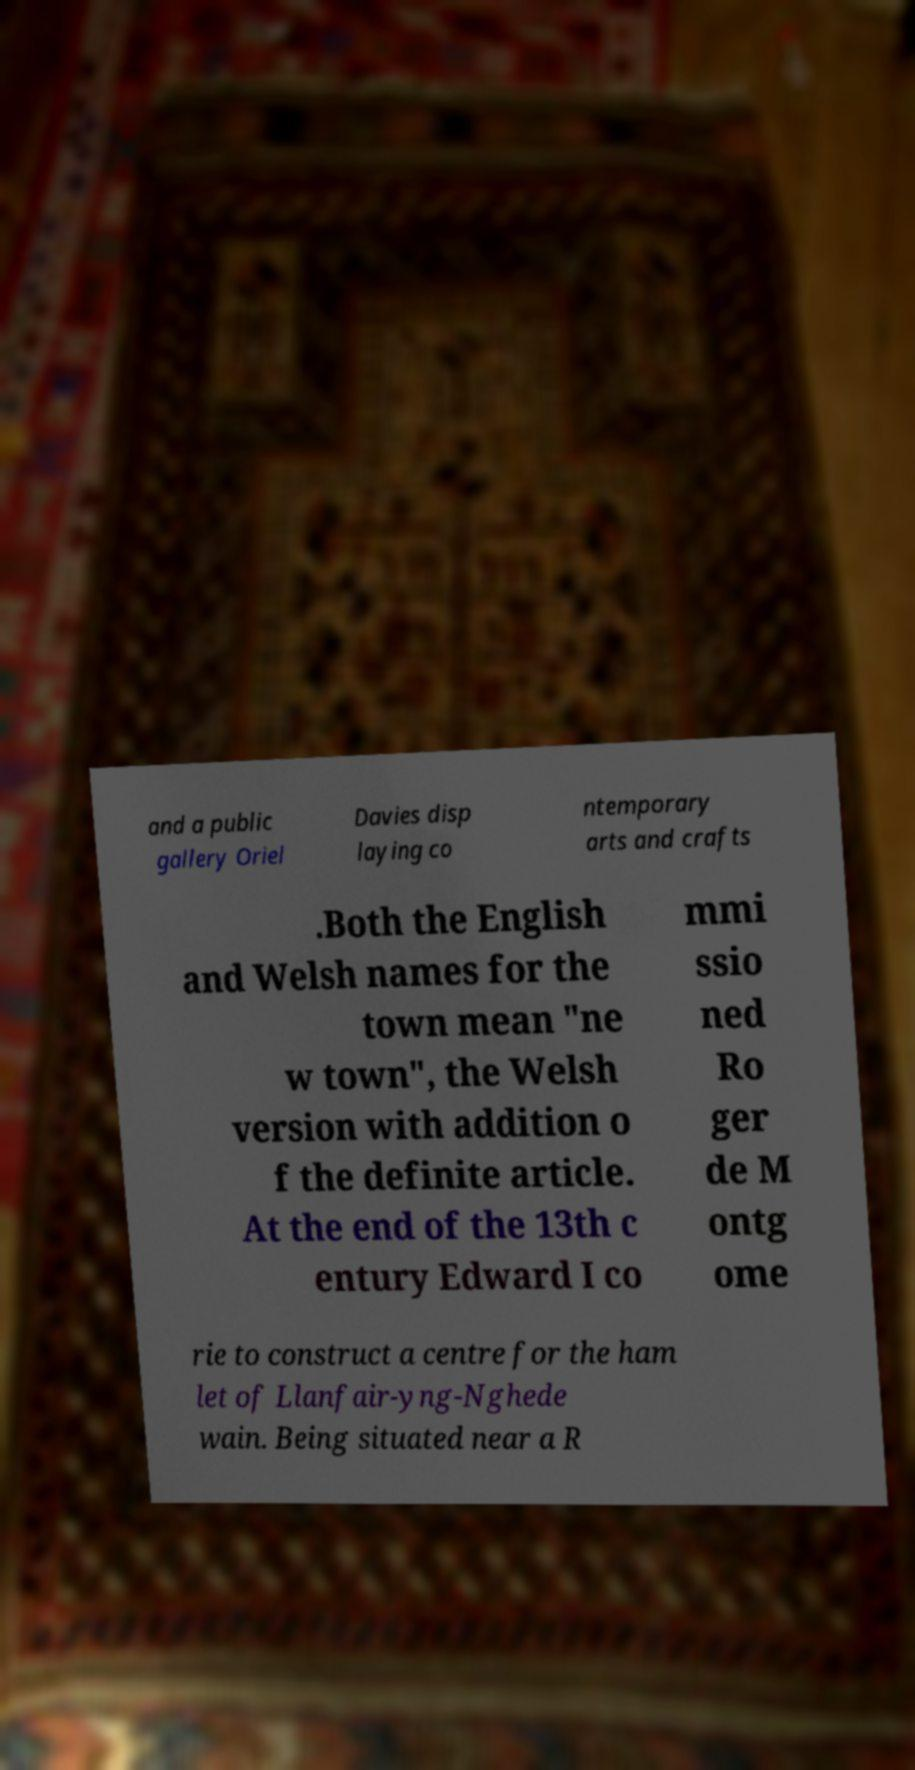For documentation purposes, I need the text within this image transcribed. Could you provide that? and a public gallery Oriel Davies disp laying co ntemporary arts and crafts .Both the English and Welsh names for the town mean "ne w town", the Welsh version with addition o f the definite article. At the end of the 13th c entury Edward I co mmi ssio ned Ro ger de M ontg ome rie to construct a centre for the ham let of Llanfair-yng-Nghede wain. Being situated near a R 